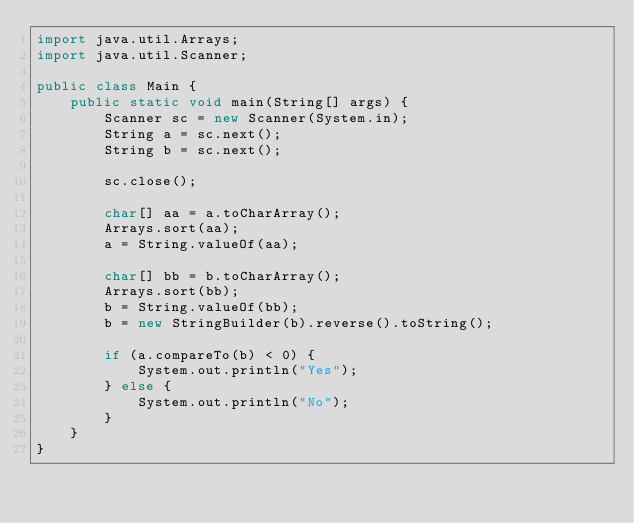<code> <loc_0><loc_0><loc_500><loc_500><_Java_>import java.util.Arrays;
import java.util.Scanner;

public class Main {
    public static void main(String[] args) {
        Scanner sc = new Scanner(System.in);
        String a = sc.next();
        String b = sc.next();

        sc.close();

        char[] aa = a.toCharArray();
        Arrays.sort(aa);
        a = String.valueOf(aa);

        char[] bb = b.toCharArray();
        Arrays.sort(bb);
        b = String.valueOf(bb);
        b = new StringBuilder(b).reverse().toString();

        if (a.compareTo(b) < 0) {
            System.out.println("Yes");
        } else {
            System.out.println("No");
        }
    }
}
</code> 